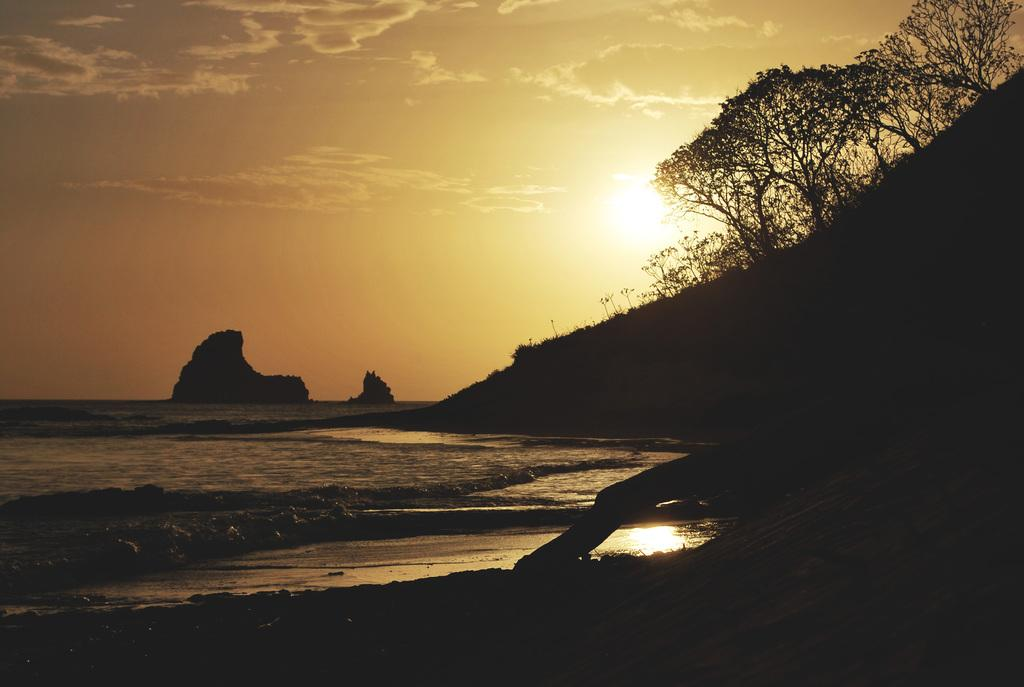What type of location is depicted in the image? There is a beach in the image. What is present at the bottom of the image? There is sand at the bottom of the image. What can be seen in the background of the image? There are trees and plants in the background of the image. What is visible at the top of the image? The sky is visible at the top of the image. What does the dad say about the goat during the week in the image? There is no dad, goat, or mention of a week present in the image. 